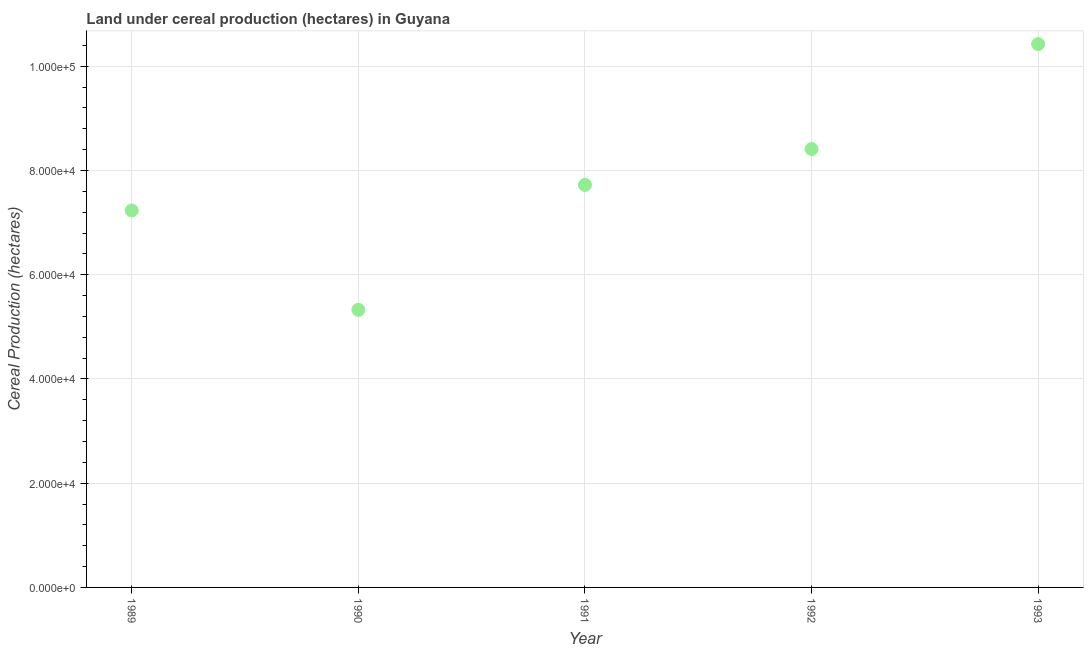What is the land under cereal production in 1989?
Keep it short and to the point. 7.23e+04. Across all years, what is the maximum land under cereal production?
Ensure brevity in your answer.  1.04e+05. Across all years, what is the minimum land under cereal production?
Make the answer very short. 5.33e+04. In which year was the land under cereal production maximum?
Ensure brevity in your answer.  1993. What is the sum of the land under cereal production?
Your answer should be very brief. 3.91e+05. What is the difference between the land under cereal production in 1989 and 1992?
Your response must be concise. -1.18e+04. What is the average land under cereal production per year?
Provide a succinct answer. 7.82e+04. What is the median land under cereal production?
Make the answer very short. 7.72e+04. In how many years, is the land under cereal production greater than 76000 hectares?
Keep it short and to the point. 3. Do a majority of the years between 1990 and 1989 (inclusive) have land under cereal production greater than 32000 hectares?
Ensure brevity in your answer.  No. What is the ratio of the land under cereal production in 1989 to that in 1993?
Offer a terse response. 0.69. Is the land under cereal production in 1989 less than that in 1992?
Your response must be concise. Yes. Is the difference between the land under cereal production in 1991 and 1993 greater than the difference between any two years?
Offer a very short reply. No. What is the difference between the highest and the second highest land under cereal production?
Offer a terse response. 2.01e+04. Is the sum of the land under cereal production in 1992 and 1993 greater than the maximum land under cereal production across all years?
Provide a succinct answer. Yes. What is the difference between the highest and the lowest land under cereal production?
Provide a short and direct response. 5.10e+04. How many dotlines are there?
Keep it short and to the point. 1. Are the values on the major ticks of Y-axis written in scientific E-notation?
Make the answer very short. Yes. Does the graph contain any zero values?
Provide a short and direct response. No. Does the graph contain grids?
Offer a terse response. Yes. What is the title of the graph?
Your answer should be compact. Land under cereal production (hectares) in Guyana. What is the label or title of the X-axis?
Offer a very short reply. Year. What is the label or title of the Y-axis?
Offer a terse response. Cereal Production (hectares). What is the Cereal Production (hectares) in 1989?
Offer a terse response. 7.23e+04. What is the Cereal Production (hectares) in 1990?
Your answer should be compact. 5.33e+04. What is the Cereal Production (hectares) in 1991?
Offer a very short reply. 7.72e+04. What is the Cereal Production (hectares) in 1992?
Provide a short and direct response. 8.41e+04. What is the Cereal Production (hectares) in 1993?
Make the answer very short. 1.04e+05. What is the difference between the Cereal Production (hectares) in 1989 and 1990?
Make the answer very short. 1.91e+04. What is the difference between the Cereal Production (hectares) in 1989 and 1991?
Give a very brief answer. -4913. What is the difference between the Cereal Production (hectares) in 1989 and 1992?
Provide a succinct answer. -1.18e+04. What is the difference between the Cereal Production (hectares) in 1989 and 1993?
Make the answer very short. -3.19e+04. What is the difference between the Cereal Production (hectares) in 1990 and 1991?
Give a very brief answer. -2.40e+04. What is the difference between the Cereal Production (hectares) in 1990 and 1992?
Make the answer very short. -3.09e+04. What is the difference between the Cereal Production (hectares) in 1990 and 1993?
Make the answer very short. -5.10e+04. What is the difference between the Cereal Production (hectares) in 1991 and 1992?
Give a very brief answer. -6874. What is the difference between the Cereal Production (hectares) in 1991 and 1993?
Make the answer very short. -2.70e+04. What is the difference between the Cereal Production (hectares) in 1992 and 1993?
Give a very brief answer. -2.01e+04. What is the ratio of the Cereal Production (hectares) in 1989 to that in 1990?
Provide a succinct answer. 1.36. What is the ratio of the Cereal Production (hectares) in 1989 to that in 1991?
Offer a very short reply. 0.94. What is the ratio of the Cereal Production (hectares) in 1989 to that in 1992?
Your answer should be very brief. 0.86. What is the ratio of the Cereal Production (hectares) in 1989 to that in 1993?
Provide a short and direct response. 0.69. What is the ratio of the Cereal Production (hectares) in 1990 to that in 1991?
Offer a very short reply. 0.69. What is the ratio of the Cereal Production (hectares) in 1990 to that in 1992?
Provide a succinct answer. 0.63. What is the ratio of the Cereal Production (hectares) in 1990 to that in 1993?
Make the answer very short. 0.51. What is the ratio of the Cereal Production (hectares) in 1991 to that in 1992?
Keep it short and to the point. 0.92. What is the ratio of the Cereal Production (hectares) in 1991 to that in 1993?
Keep it short and to the point. 0.74. What is the ratio of the Cereal Production (hectares) in 1992 to that in 1993?
Your response must be concise. 0.81. 